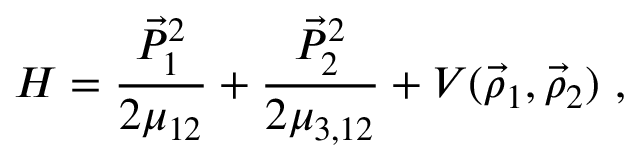Convert formula to latex. <formula><loc_0><loc_0><loc_500><loc_500>H = \frac { \vec { P } _ { 1 } ^ { 2 } } { 2 \mu _ { 1 2 } } + \frac { \vec { P } _ { 2 } ^ { 2 } } { 2 \mu _ { 3 , 1 2 } } + V ( \vec { \rho } _ { 1 } , \vec { \rho } _ { 2 } ) ,</formula> 